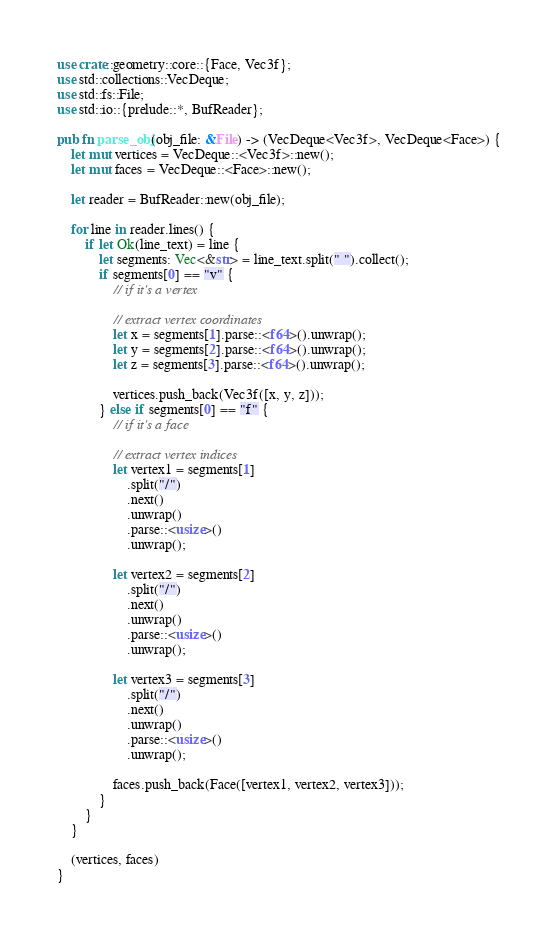<code> <loc_0><loc_0><loc_500><loc_500><_Rust_>use crate::geometry::core::{Face, Vec3f};
use std::collections::VecDeque;
use std::fs::File;
use std::io::{prelude::*, BufReader};

pub fn parse_obj(obj_file: &File) -> (VecDeque<Vec3f>, VecDeque<Face>) {
    let mut vertices = VecDeque::<Vec3f>::new();
    let mut faces = VecDeque::<Face>::new();

    let reader = BufReader::new(obj_file);

    for line in reader.lines() {
        if let Ok(line_text) = line {
            let segments: Vec<&str> = line_text.split(" ").collect();
            if segments[0] == "v" {
                // if it's a vertex

                // extract vertex coordinates
                let x = segments[1].parse::<f64>().unwrap();
                let y = segments[2].parse::<f64>().unwrap();
                let z = segments[3].parse::<f64>().unwrap();

                vertices.push_back(Vec3f([x, y, z]));
            } else if segments[0] == "f" {
                // if it's a face

                // extract vertex indices
                let vertex1 = segments[1]
                    .split("/")
                    .next()
                    .unwrap()
                    .parse::<usize>()
                    .unwrap();

                let vertex2 = segments[2]
                    .split("/")
                    .next()
                    .unwrap()
                    .parse::<usize>()
                    .unwrap();

                let vertex3 = segments[3]
                    .split("/")
                    .next()
                    .unwrap()
                    .parse::<usize>()
                    .unwrap();

                faces.push_back(Face([vertex1, vertex2, vertex3]));
            }
        }
    }

    (vertices, faces)
}
</code> 